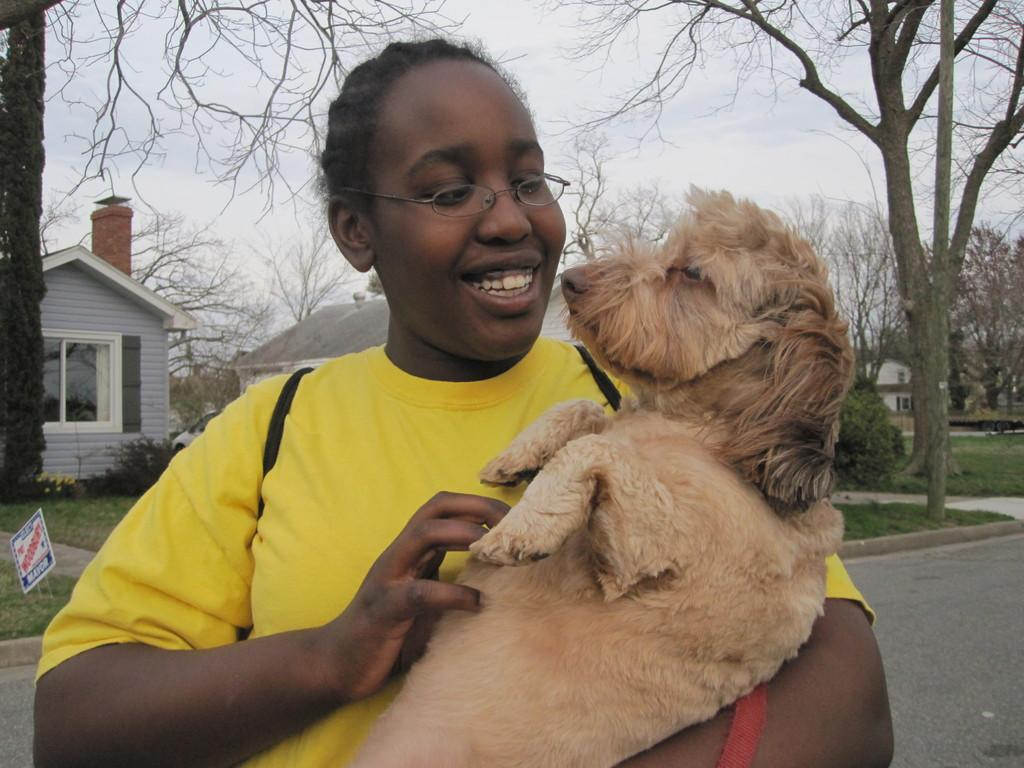Who is the main subject in the image? There is a woman in the image. What is the woman doing in the image? The woman is carrying a dog. What can be seen in the background of the image? There are buildings, trees, and the sky visible in the background of the image. What type of machine is being used to pull the dog in the image? There is no machine present in the image; the woman is carrying the dog. What color is the light emitted by the dog in the image? There is no light emitted by the dog in the image, as it is a real dog and not a source of light. 